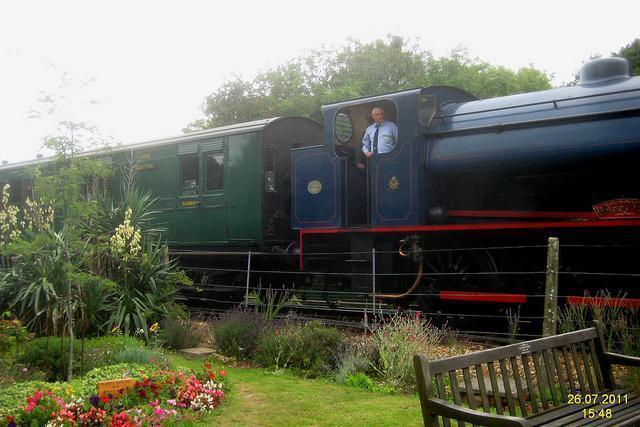What is the man wearing?
Choose the right answer and clarify with the format: 'Answer: answer
Rationale: rationale.'
Options: Tie, sunglasses, suspenders, backpack. Answer: tie.
Rationale: The man has a tie on his neck. 